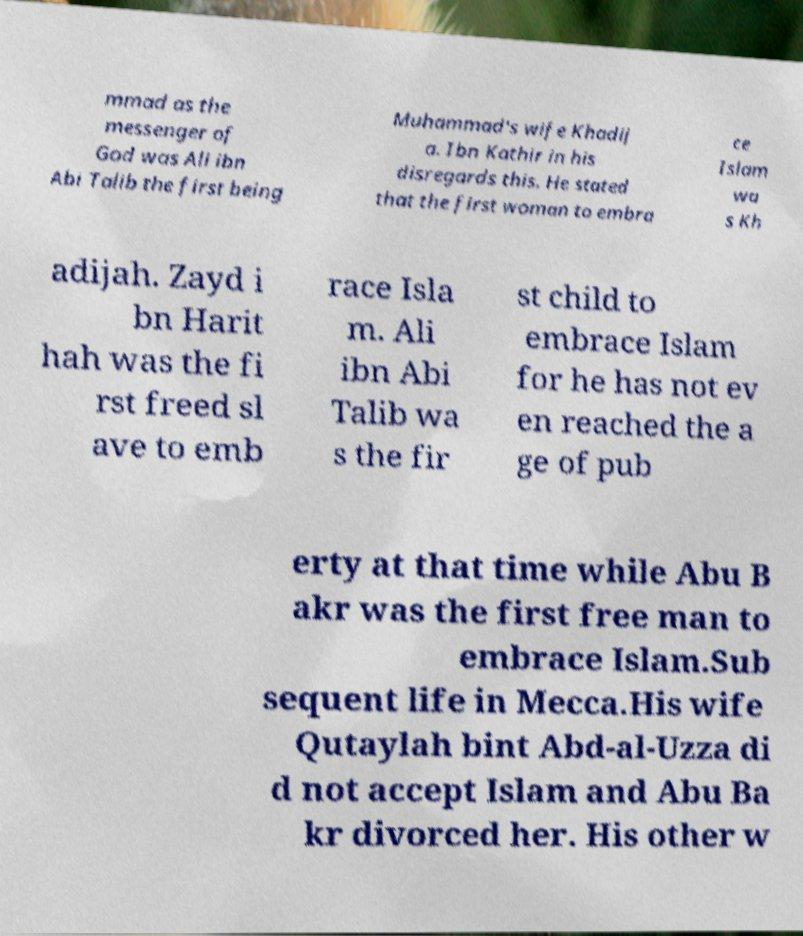Could you assist in decoding the text presented in this image and type it out clearly? mmad as the messenger of God was Ali ibn Abi Talib the first being Muhammad's wife Khadij a. Ibn Kathir in his disregards this. He stated that the first woman to embra ce Islam wa s Kh adijah. Zayd i bn Harit hah was the fi rst freed sl ave to emb race Isla m. Ali ibn Abi Talib wa s the fir st child to embrace Islam for he has not ev en reached the a ge of pub erty at that time while Abu B akr was the first free man to embrace Islam.Sub sequent life in Mecca.His wife Qutaylah bint Abd-al-Uzza di d not accept Islam and Abu Ba kr divorced her. His other w 